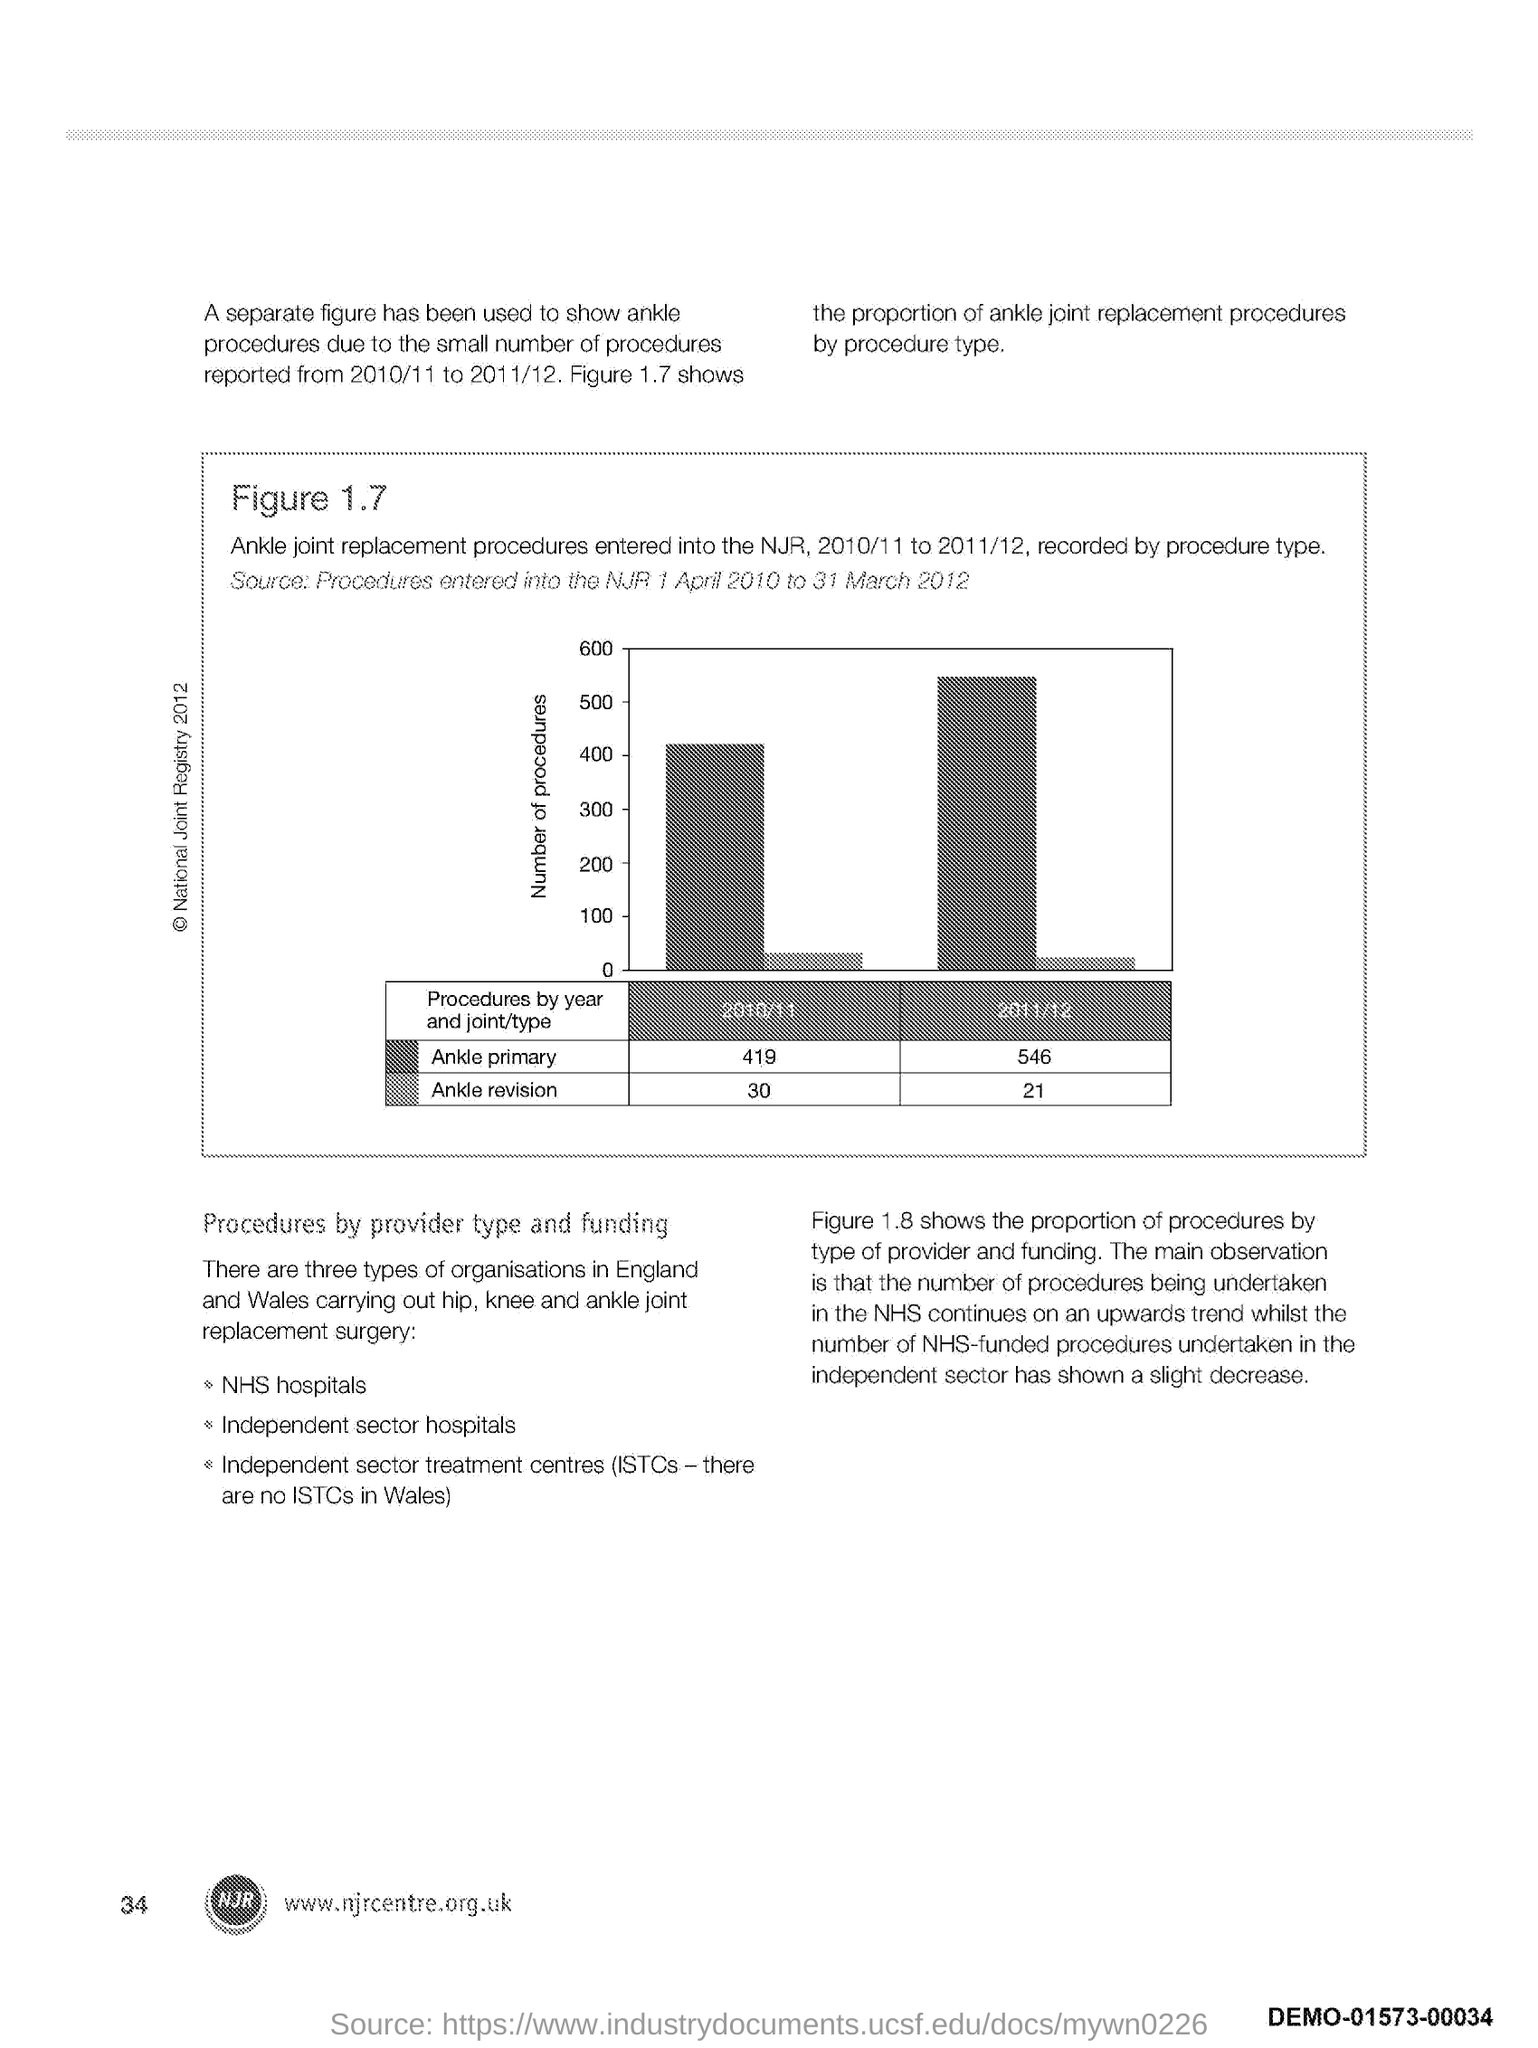What is plotted in the y-axis?
Your answer should be compact. Number of procedures. What is the Page Number?
Your answer should be compact. 34. 